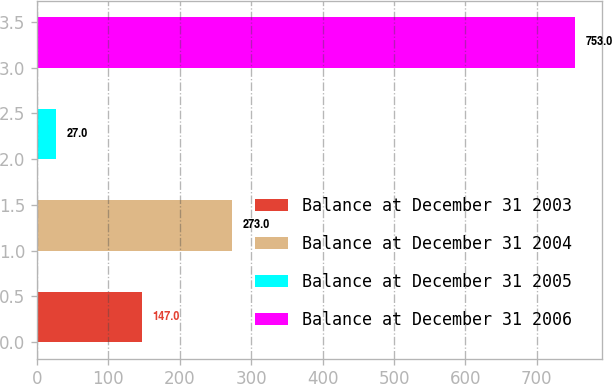<chart> <loc_0><loc_0><loc_500><loc_500><bar_chart><fcel>Balance at December 31 2003<fcel>Balance at December 31 2004<fcel>Balance at December 31 2005<fcel>Balance at December 31 2006<nl><fcel>147<fcel>273<fcel>27<fcel>753<nl></chart> 